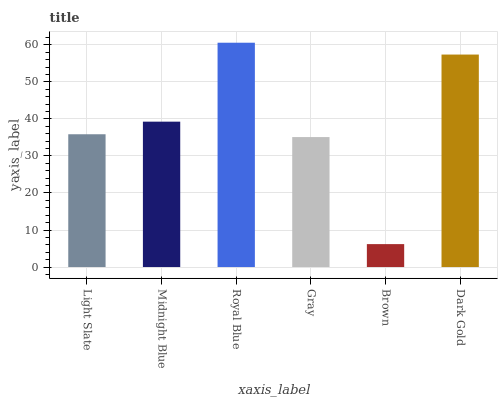Is Brown the minimum?
Answer yes or no. Yes. Is Royal Blue the maximum?
Answer yes or no. Yes. Is Midnight Blue the minimum?
Answer yes or no. No. Is Midnight Blue the maximum?
Answer yes or no. No. Is Midnight Blue greater than Light Slate?
Answer yes or no. Yes. Is Light Slate less than Midnight Blue?
Answer yes or no. Yes. Is Light Slate greater than Midnight Blue?
Answer yes or no. No. Is Midnight Blue less than Light Slate?
Answer yes or no. No. Is Midnight Blue the high median?
Answer yes or no. Yes. Is Light Slate the low median?
Answer yes or no. Yes. Is Dark Gold the high median?
Answer yes or no. No. Is Dark Gold the low median?
Answer yes or no. No. 